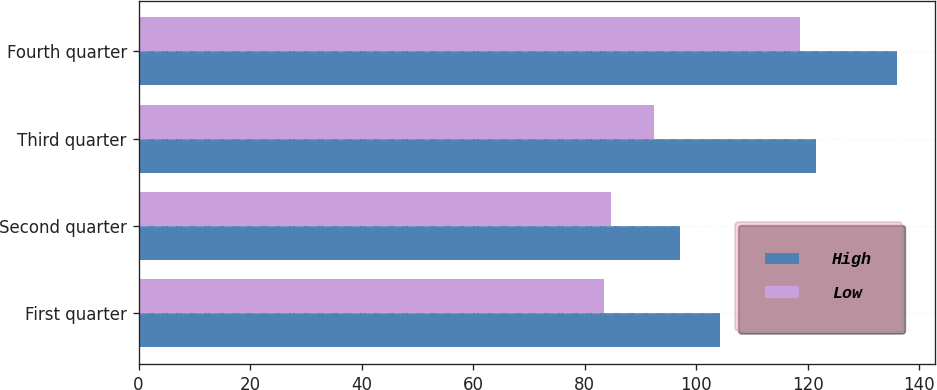Convert chart to OTSL. <chart><loc_0><loc_0><loc_500><loc_500><stacked_bar_chart><ecel><fcel>First quarter<fcel>Second quarter<fcel>Third quarter<fcel>Fourth quarter<nl><fcel>High<fcel>104.3<fcel>97.11<fcel>121.56<fcel>136.08<nl><fcel>Low<fcel>83.5<fcel>84.79<fcel>92.45<fcel>118.66<nl></chart> 